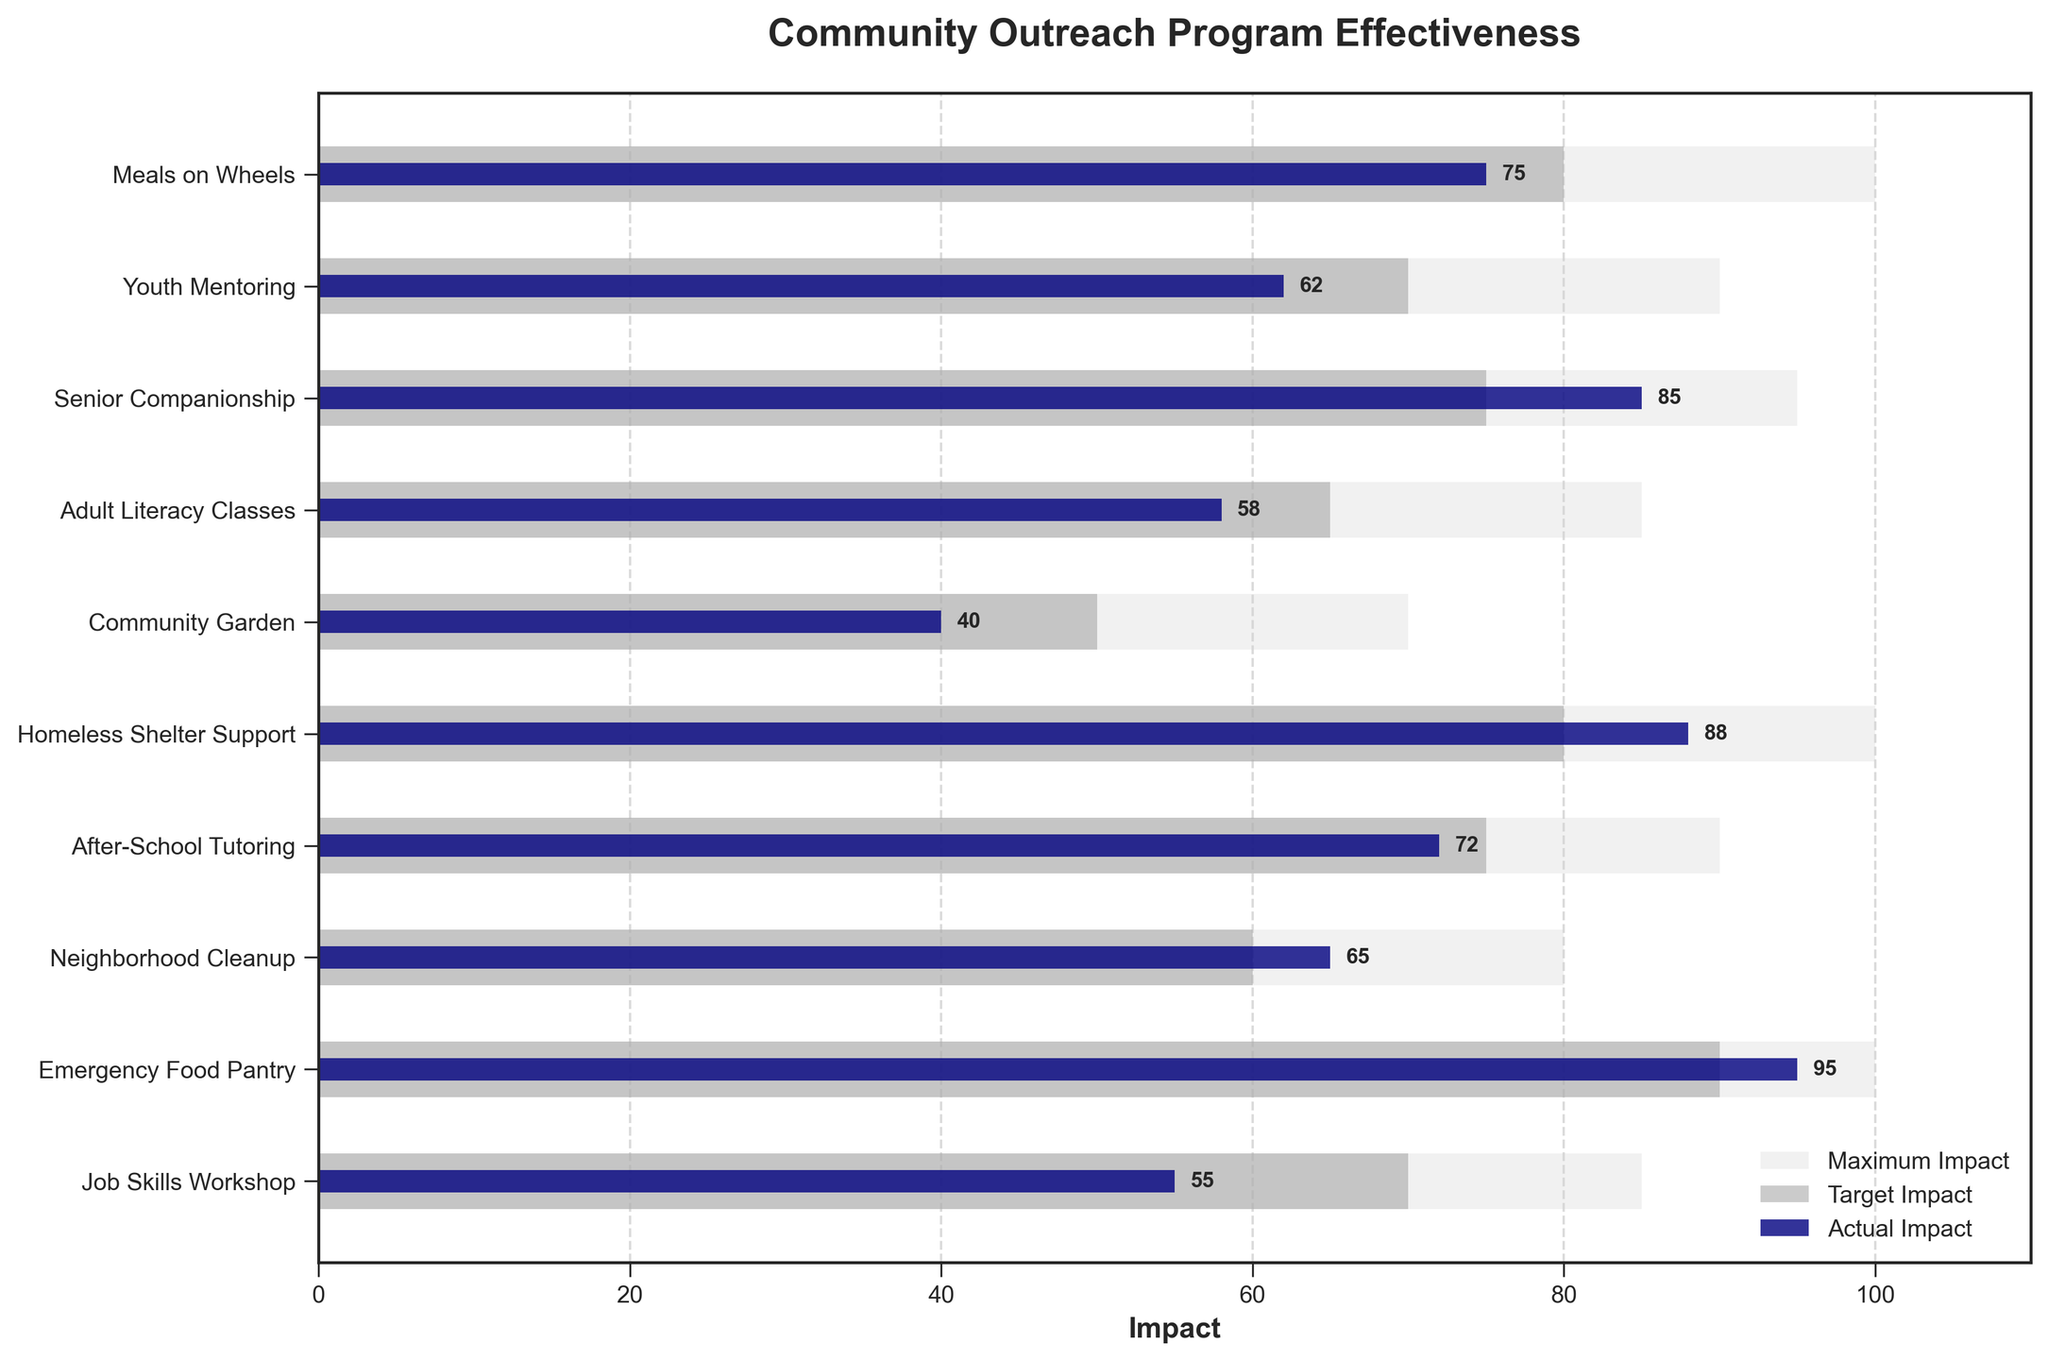What is the title of the figure? The title of the figure is typically located at the top of the chart. In this case, it reads "Community Outreach Program Effectiveness."
Answer: Community Outreach Program Effectiveness Which program has the highest actual impact? The highest actual impact is the bar that extends the furthest to the right among the navy bars. The Emergency Food Pantry has the highest actual impact with a value of 95.
Answer: Emergency Food Pantry What are the colors used to represent the maximum and target impacts? By observing the reference bars, the maximum impact is represented by a light grey color, and the target impact is represented by a dark grey color.
Answer: Light grey and dark grey How many programs have an actual impact greater than or equal to their target impact? We identify each navy bar (actual impact) that is equal to or exceeds the dark grey bar (target impact) for the same program. These programs are Senior Companionship, Homeless Shelter Support, Neighborhood Cleanup, and Emergency Food Pantry.
Answer: Four programs Are there any programs where the actual impact is below 50? Scan the navy bars to find any values below 50. The Community Garden and Job Skills Workshop have actual impacts below 50.
Answer: Yes Which program exceeded its maximum impact? Maximum impact is represented by light grey bars. No navy bars (actual impact) extend beyond their respective light grey bars (maximum impact). Therefore, no program exceeded its maximum impact.
Answer: None What is the actual impact difference between the program with the highest and lowest effectiveness? Identify the highest and lowest actual impacts. Highest is Emergency Food Pantry (95) and lowest is Community Garden (40). Compute the difference: 95 - 40 = 55.
Answer: 55 Which programs have an actual impact that falls short of their target by more than 10 units? Compare actual and target impacts, find differences greater than 10 units. Programs: Meals on Wheels (5), Youth Mentoring (8), Adult Literacy Classes (7), Community Garden (by 10) and Job Skills Workshop (by 15).
Answer: None How does the actual impact of Youth Mentoring compare to its target impact? Youth Mentoring's actual impact (62) compared to its target (70): 70 - 62 = 8 units below target.
Answer: 8 units below target What is the average actual impact across all the programs? Sum all actual impacts (75 + 62 + 85 + 58 + 40 + 88 + 72 + 65 + 95 + 55) = 695. Divide by the number of programs (10): 695 / 10 = 69.5.
Answer: 69.5 